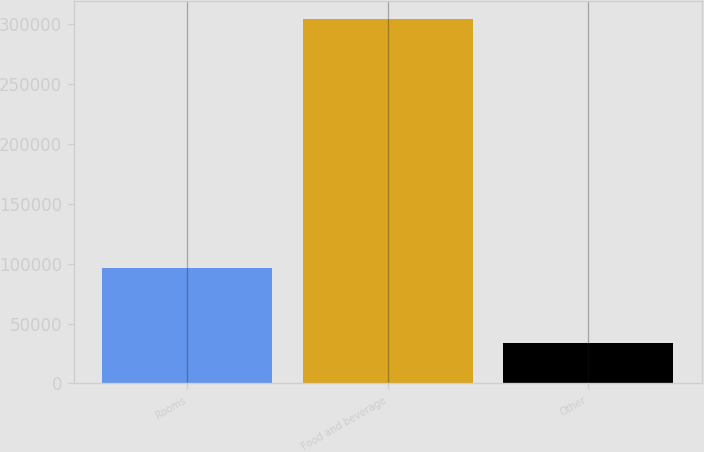<chart> <loc_0><loc_0><loc_500><loc_500><bar_chart><fcel>Rooms<fcel>Food and beverage<fcel>Other<nl><fcel>96183<fcel>303900<fcel>33457<nl></chart> 